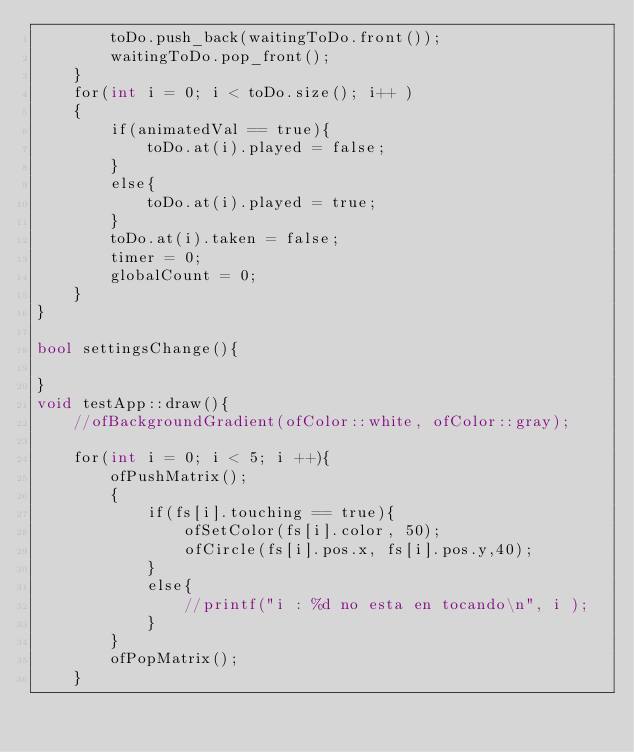Convert code to text. <code><loc_0><loc_0><loc_500><loc_500><_ObjectiveC_>        toDo.push_back(waitingToDo.front());
        waitingToDo.pop_front();
    }
    for(int i = 0; i < toDo.size(); i++ )
    {
        if(animatedVal == true){
            toDo.at(i).played = false;
        }
        else{
            toDo.at(i).played = true;
        }
        toDo.at(i).taken = false;
        timer = 0;
        globalCount = 0;
    }
}

bool settingsChange(){
    
}
void testApp::draw(){
    //ofBackgroundGradient(ofColor::white, ofColor::gray);
    
    for(int i = 0; i < 5; i ++){
        ofPushMatrix();
        {
            if(fs[i].touching == true){
                ofSetColor(fs[i].color, 50);
                ofCircle(fs[i].pos.x, fs[i].pos.y,40);
            }
            else{
                //printf("i : %d no esta en tocando\n", i );
            }
        }
        ofPopMatrix();
    }</code> 